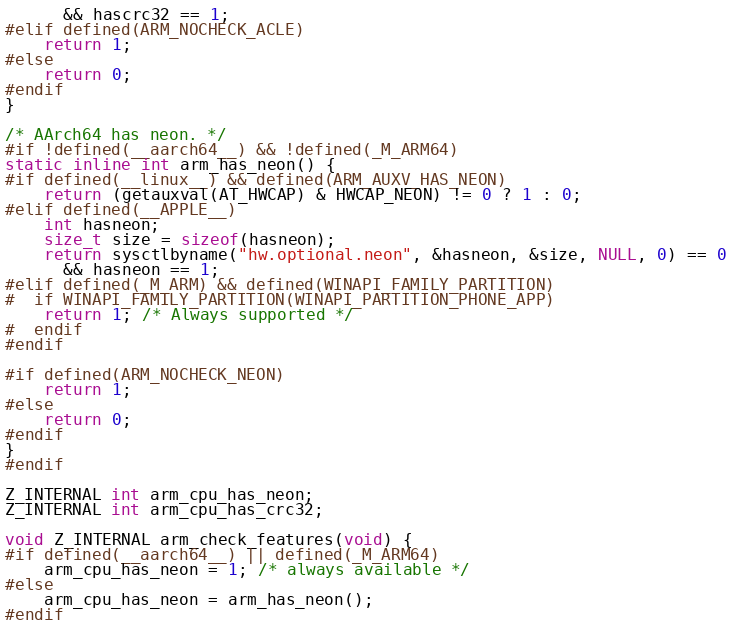<code> <loc_0><loc_0><loc_500><loc_500><_C_>      && hascrc32 == 1;
#elif defined(ARM_NOCHECK_ACLE)
    return 1;
#else
    return 0;
#endif
}

/* AArch64 has neon. */
#if !defined(__aarch64__) && !defined(_M_ARM64)
static inline int arm_has_neon() {
#if defined(__linux__) && defined(ARM_AUXV_HAS_NEON)
    return (getauxval(AT_HWCAP) & HWCAP_NEON) != 0 ? 1 : 0;
#elif defined(__APPLE__)
    int hasneon;
    size_t size = sizeof(hasneon);
    return sysctlbyname("hw.optional.neon", &hasneon, &size, NULL, 0) == 0
      && hasneon == 1;
#elif defined(_M_ARM) && defined(WINAPI_FAMILY_PARTITION)
#  if WINAPI_FAMILY_PARTITION(WINAPI_PARTITION_PHONE_APP)
    return 1; /* Always supported */
#  endif
#endif

#if defined(ARM_NOCHECK_NEON)
    return 1;
#else
    return 0;
#endif
}
#endif

Z_INTERNAL int arm_cpu_has_neon;
Z_INTERNAL int arm_cpu_has_crc32;

void Z_INTERNAL arm_check_features(void) {
#if defined(__aarch64__) || defined(_M_ARM64)
    arm_cpu_has_neon = 1; /* always available */
#else
    arm_cpu_has_neon = arm_has_neon();
#endif</code> 